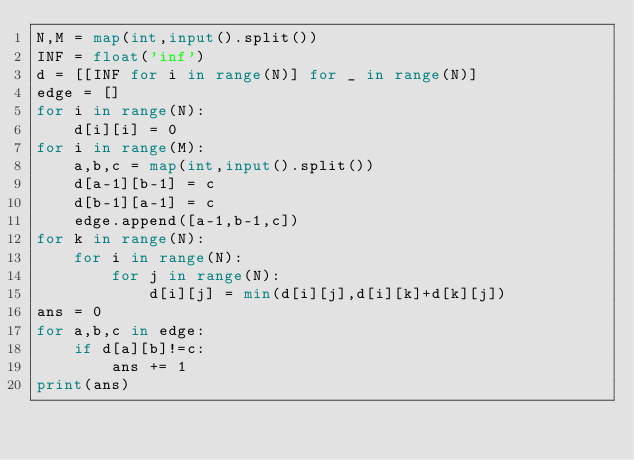Convert code to text. <code><loc_0><loc_0><loc_500><loc_500><_Python_>N,M = map(int,input().split())
INF = float('inf')
d = [[INF for i in range(N)] for _ in range(N)]
edge = []
for i in range(N):
    d[i][i] = 0
for i in range(M):
    a,b,c = map(int,input().split())
    d[a-1][b-1] = c
    d[b-1][a-1] = c
    edge.append([a-1,b-1,c])
for k in range(N):
    for i in range(N):
        for j in range(N):
            d[i][j] = min(d[i][j],d[i][k]+d[k][j])
ans = 0
for a,b,c in edge:
    if d[a][b]!=c:
        ans += 1
print(ans)
</code> 